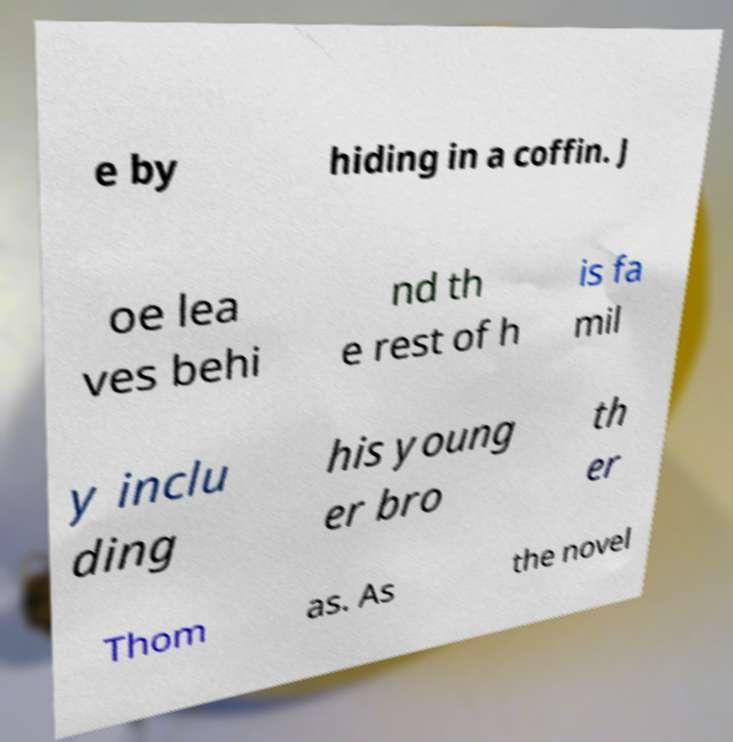Please read and relay the text visible in this image. What does it say? e by hiding in a coffin. J oe lea ves behi nd th e rest of h is fa mil y inclu ding his young er bro th er Thom as. As the novel 